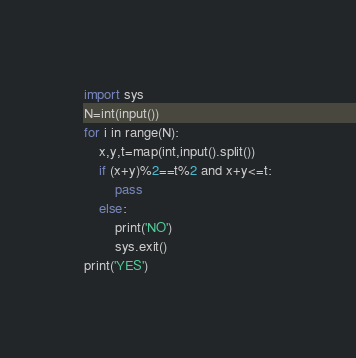<code> <loc_0><loc_0><loc_500><loc_500><_Python_>import sys
N=int(input())
for i in range(N):
    x,y,t=map(int,input().split())
    if (x+y)%2==t%2 and x+y<=t:
        pass
    else:
        print('NO')
        sys.exit()
print('YES')
</code> 